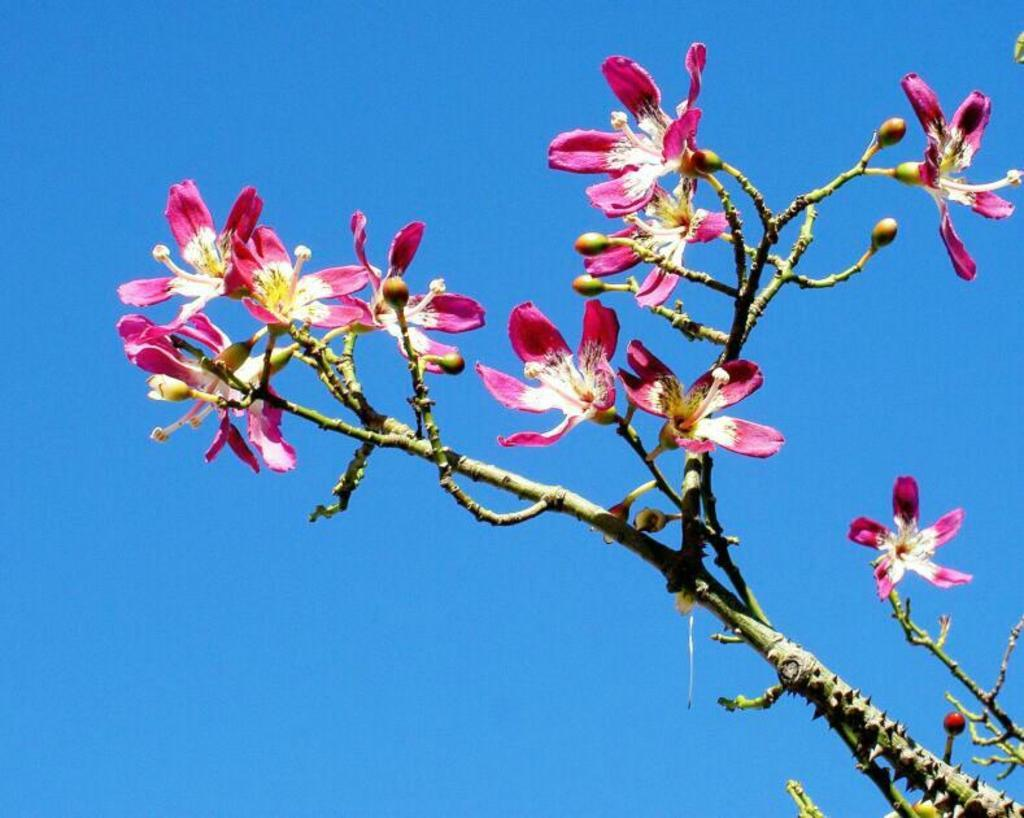What type of living organisms can be seen in the image? Flowers, buds, and plants can be seen in the image. Can you describe the growth stage of some of the plants in the image? Yes, there are buds in the image, which are indicative of plants in the early stages of growth. What other types of plants might be present in the image? Since there are flowers and buds, it is likely that there are also fully grown plants in the image. What type of cactus can be seen in the image? There is no cactus present in the image. How low does the plant in the image grow? The image does not provide information about the height or growth pattern of the plants. 